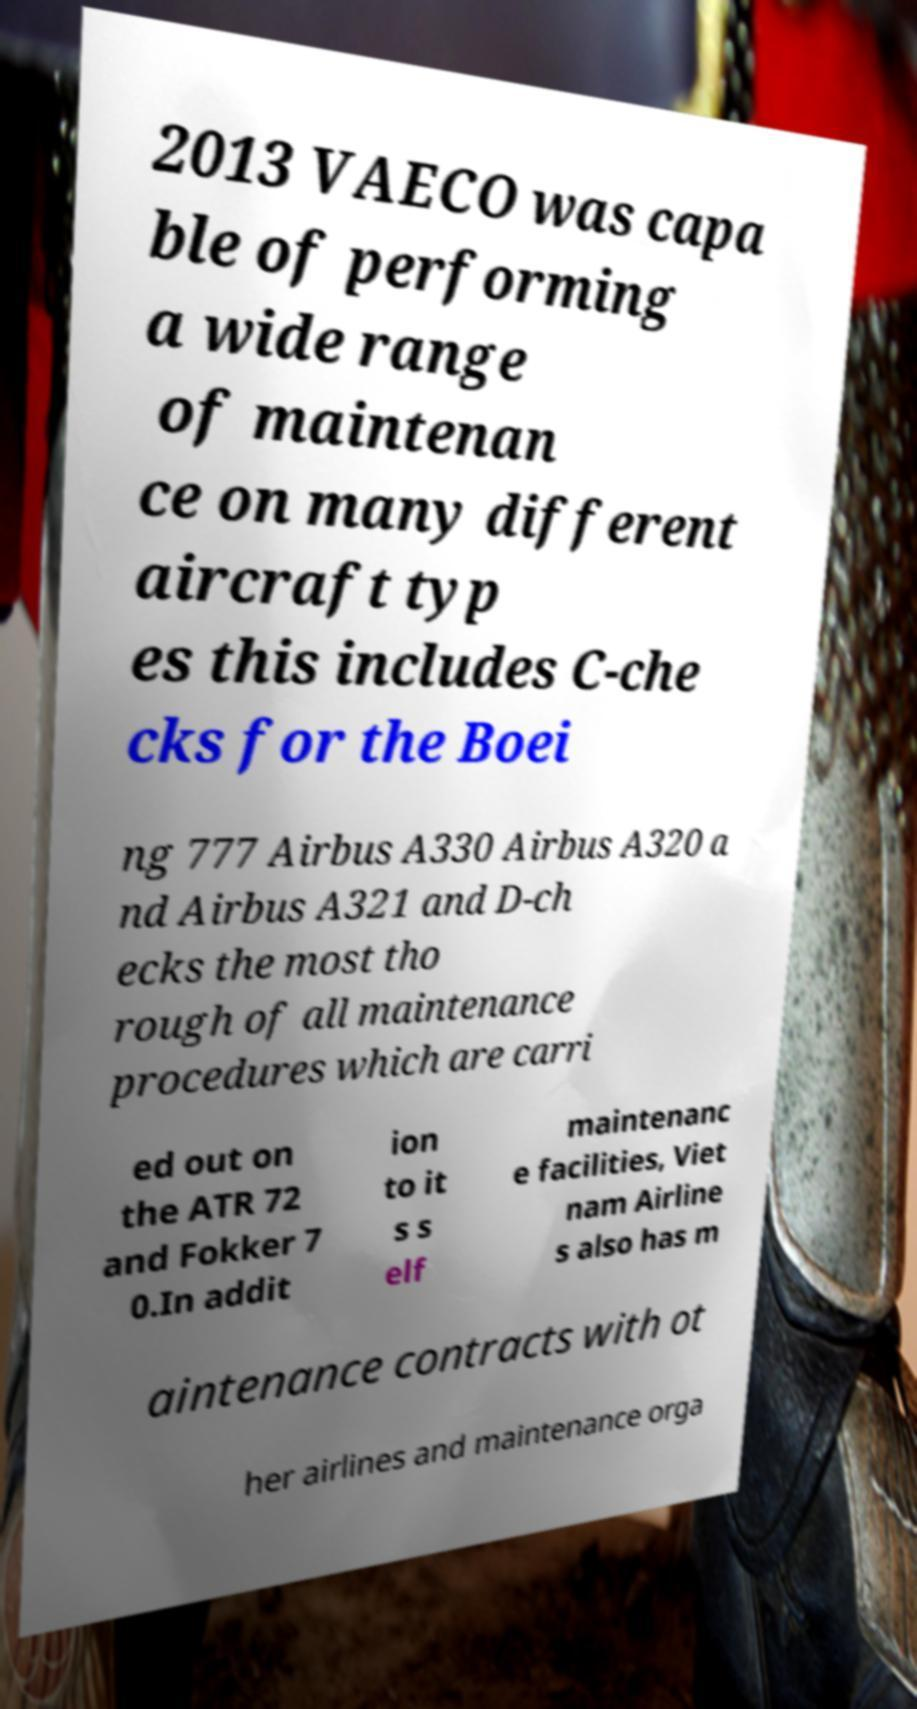For documentation purposes, I need the text within this image transcribed. Could you provide that? 2013 VAECO was capa ble of performing a wide range of maintenan ce on many different aircraft typ es this includes C-che cks for the Boei ng 777 Airbus A330 Airbus A320 a nd Airbus A321 and D-ch ecks the most tho rough of all maintenance procedures which are carri ed out on the ATR 72 and Fokker 7 0.In addit ion to it s s elf maintenanc e facilities, Viet nam Airline s also has m aintenance contracts with ot her airlines and maintenance orga 